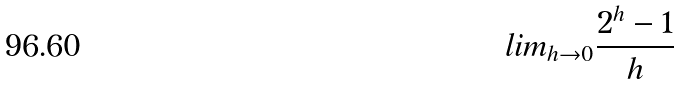Convert formula to latex. <formula><loc_0><loc_0><loc_500><loc_500>l i m _ { h \rightarrow 0 } \frac { 2 ^ { h } - 1 } { h }</formula> 